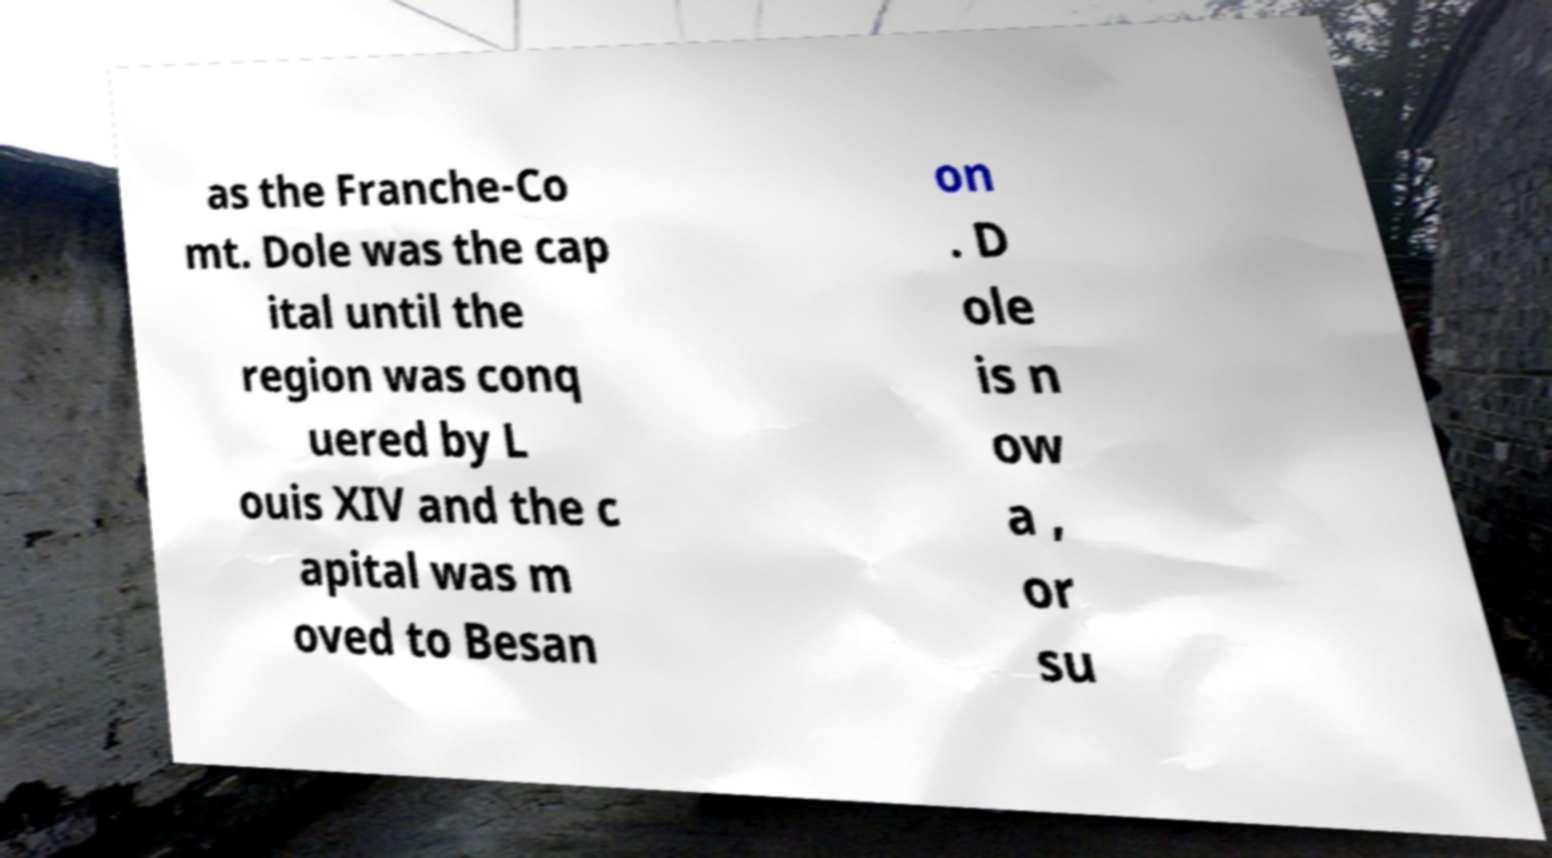Could you assist in decoding the text presented in this image and type it out clearly? as the Franche-Co mt. Dole was the cap ital until the region was conq uered by L ouis XIV and the c apital was m oved to Besan on . D ole is n ow a , or su 